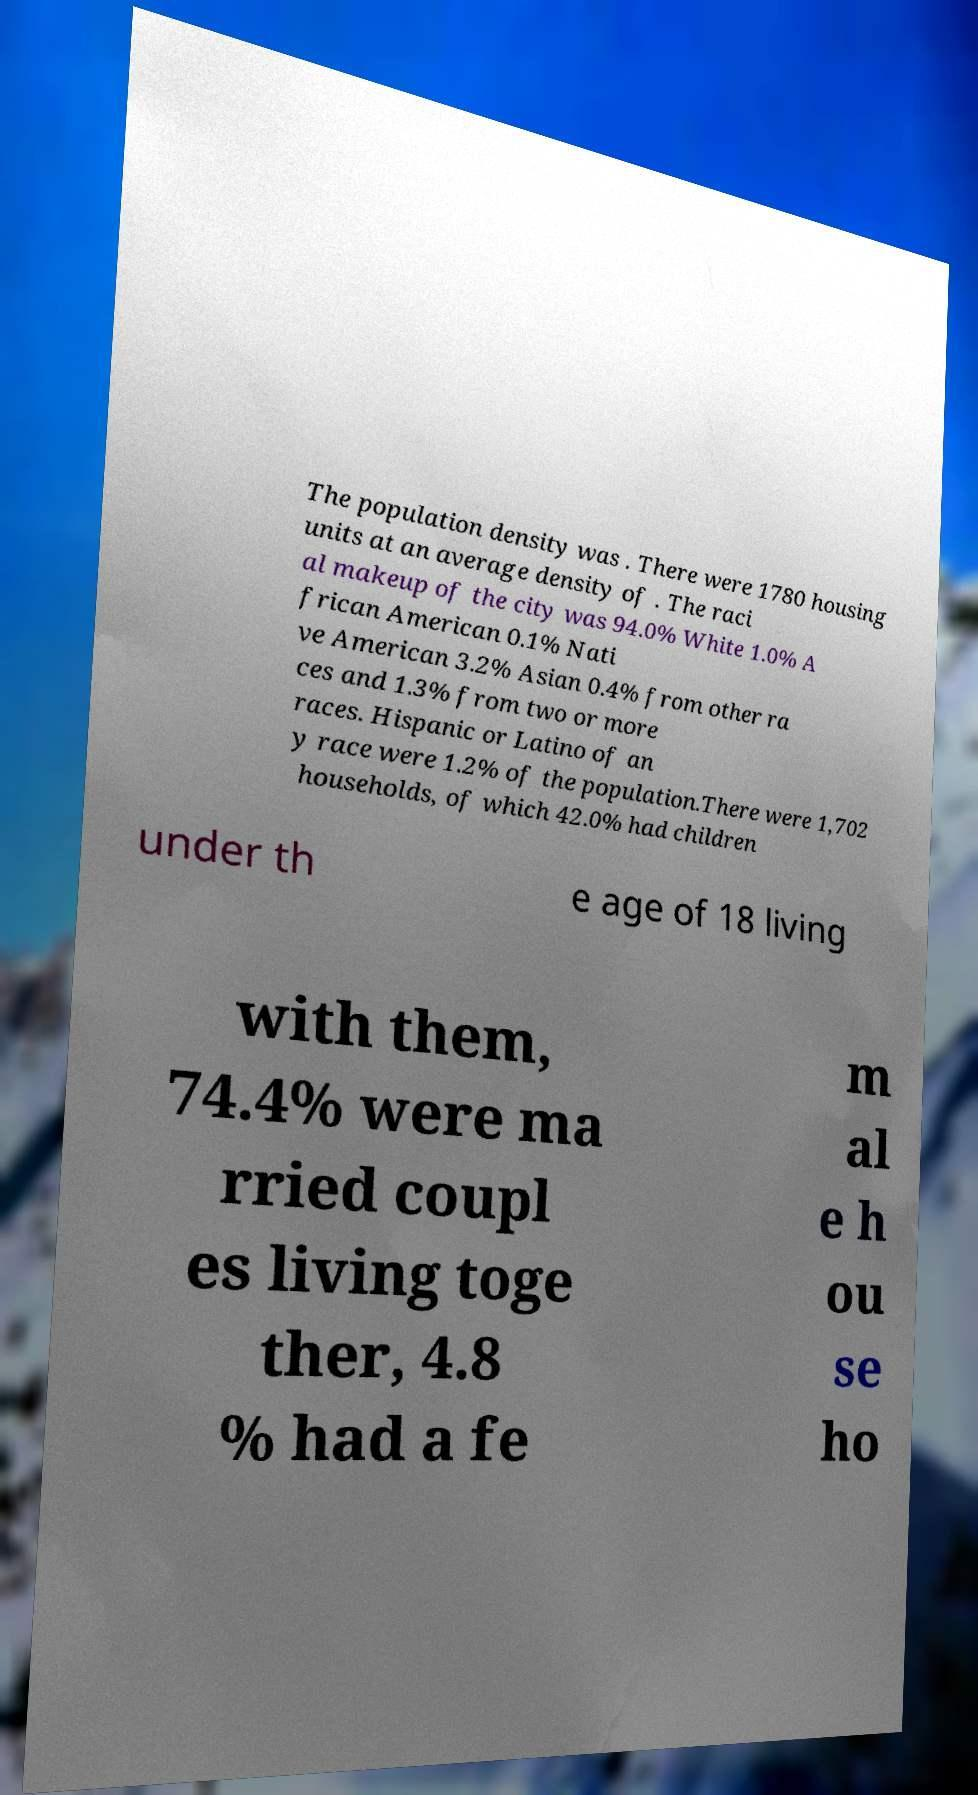Please read and relay the text visible in this image. What does it say? The population density was . There were 1780 housing units at an average density of . The raci al makeup of the city was 94.0% White 1.0% A frican American 0.1% Nati ve American 3.2% Asian 0.4% from other ra ces and 1.3% from two or more races. Hispanic or Latino of an y race were 1.2% of the population.There were 1,702 households, of which 42.0% had children under th e age of 18 living with them, 74.4% were ma rried coupl es living toge ther, 4.8 % had a fe m al e h ou se ho 